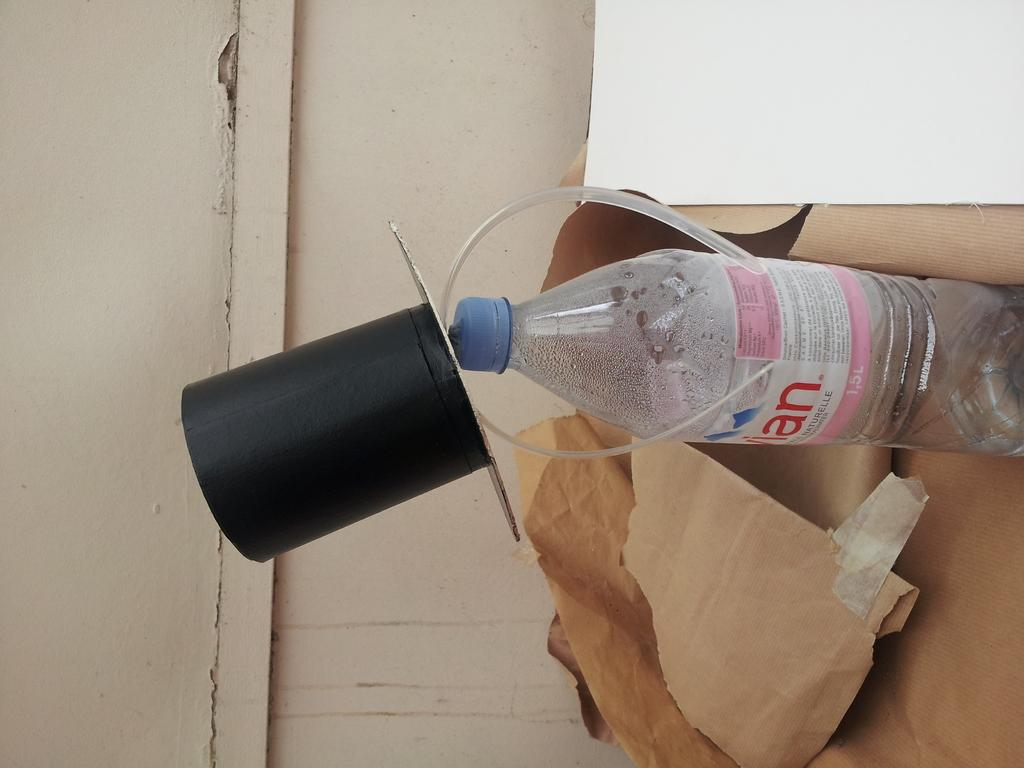<image>
Offer a succinct explanation of the picture presented. A bottle of water with the letters A and N on the label. 